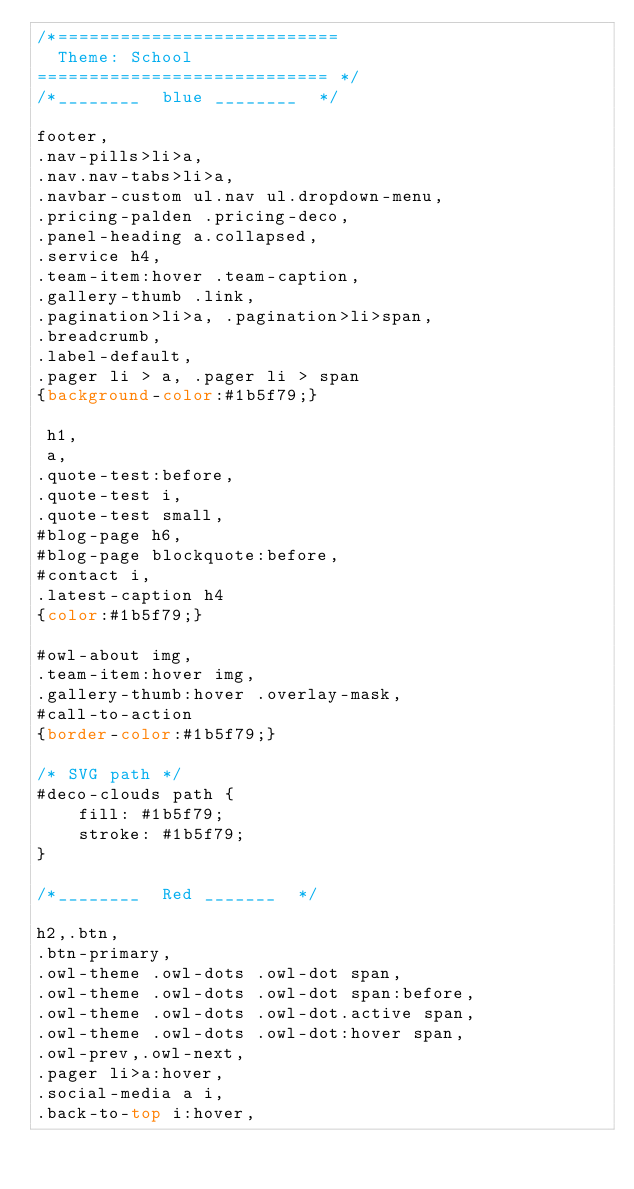<code> <loc_0><loc_0><loc_500><loc_500><_CSS_>/*===========================
  Theme: School
============================ */
/*________  blue ________  */

footer,
.nav-pills>li>a,
.nav.nav-tabs>li>a,
.navbar-custom ul.nav ul.dropdown-menu,
.pricing-palden .pricing-deco,
.panel-heading a.collapsed,
.service h4,
.team-item:hover .team-caption,
.gallery-thumb .link,
.pagination>li>a, .pagination>li>span,
.breadcrumb,
.label-default,
.pager li > a, .pager li > span
{background-color:#1b5f79;}

 h1,
 a,
.quote-test:before,
.quote-test i,
.quote-test small,
#blog-page h6,
#blog-page blockquote:before,
#contact i,
.latest-caption h4
{color:#1b5f79;}

#owl-about img,
.team-item:hover img,
.gallery-thumb:hover .overlay-mask,
#call-to-action
{border-color:#1b5f79;}

/* SVG path */
#deco-clouds path {
	fill: #1b5f79;
	stroke: #1b5f79;
}

/*________  Red _______  */

h2,.btn,
.btn-primary,
.owl-theme .owl-dots .owl-dot span,
.owl-theme .owl-dots .owl-dot span:before,
.owl-theme .owl-dots .owl-dot.active span,
.owl-theme .owl-dots .owl-dot:hover span,
.owl-prev,.owl-next,
.pager li>a:hover,
.social-media a i,
.back-to-top i:hover,</code> 